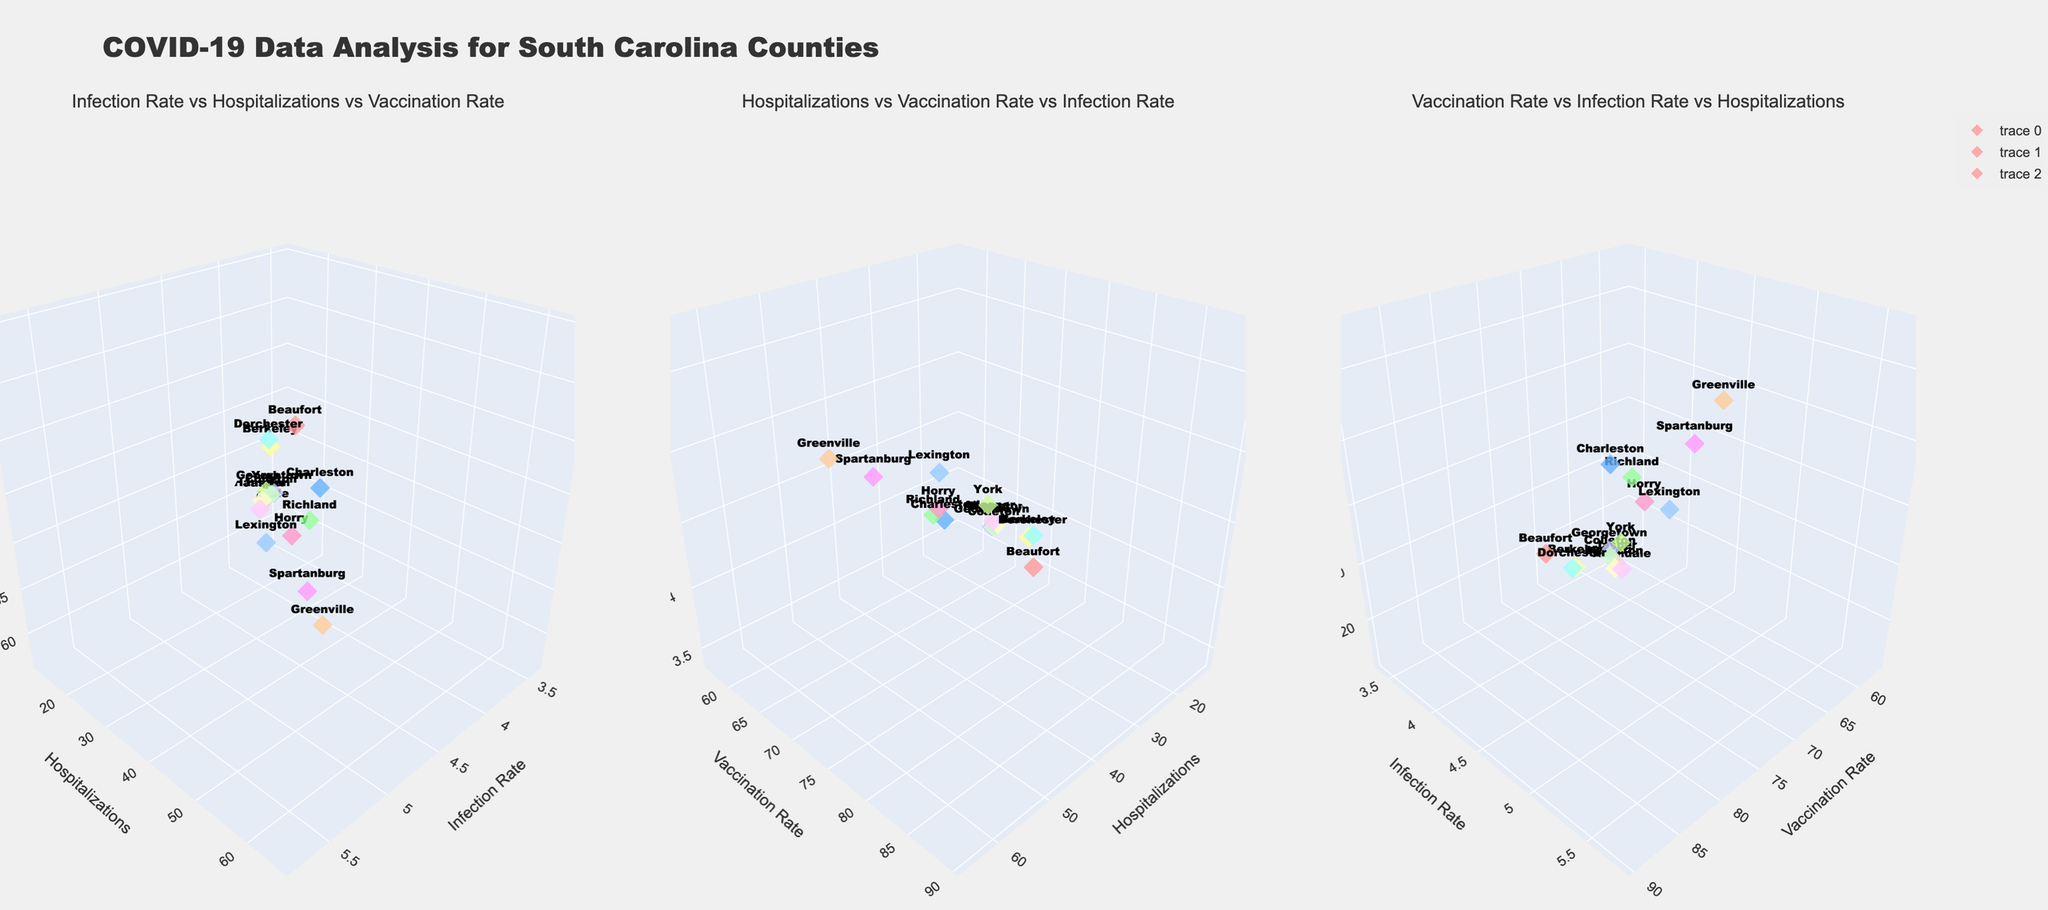what is the title of the plot? The title of the plot is prominently displayed at the top of the figure.
Answer: COVID-19 Data Analysis for South Carolina Counties How many subplots are there in the figure? By visually scanning the figure, we can see that there are three distinct 3D plots.
Answer: Three Which county has the highest hospitalization rate in the first subplot? By looking at the y-axis of the first subplot, we can see the height of the markers that represent hospitalizations. The highest point corresponds to Greenville.
Answer: Greenville What is the infection rate for Allendale county in all subplots? Across all subplots, the infection rate for Allendale county remains consistent because the data does not change. It's always the same value of 3.7 for all views.
Answer: 3.7 Which subplot shows the relationship between hospitalizations and vaccination rate versus infection rate? The second subplot depicts "Hospitalizations vs Vaccination Rate vs Infection Rate," as indicated by the subplot title.
Answer: Second subplot Compare the vaccination rates of Beaufort and Charleston counties in the third subplot. Which one is higher? In the third subplot, locate the z-axis and compare the markers for Beaufort and Charleston counties. Charleston has a higher vaccination rate (82.3) compared to Beaufort (78.5).
Answer: Charleston Which subplot addresses the relationship between vaccination rate, infection rate, and hospitalizations? The third subplot is titled "Vaccination Rate vs Infection Rate vs Hospitalizations," indicating that it addresses this relationship.
Answer: Third subplot What would be the average hospitalization rate in the first subplot if Colleton county doubled its current rate? The current rates for all counties are summed up: (32 + 56 + 48 + 61 + 38 + 42 + 35 + 29 + 52 + 31 + 25 + 18 + 22 + 15 + 12) = 516. If Colleton's rate (22) is doubled to 44, the new sum would be (516 - 22 + 44) = 538. Dividing by 15 counties gives an average of 35.87.
Answer: 35.87 